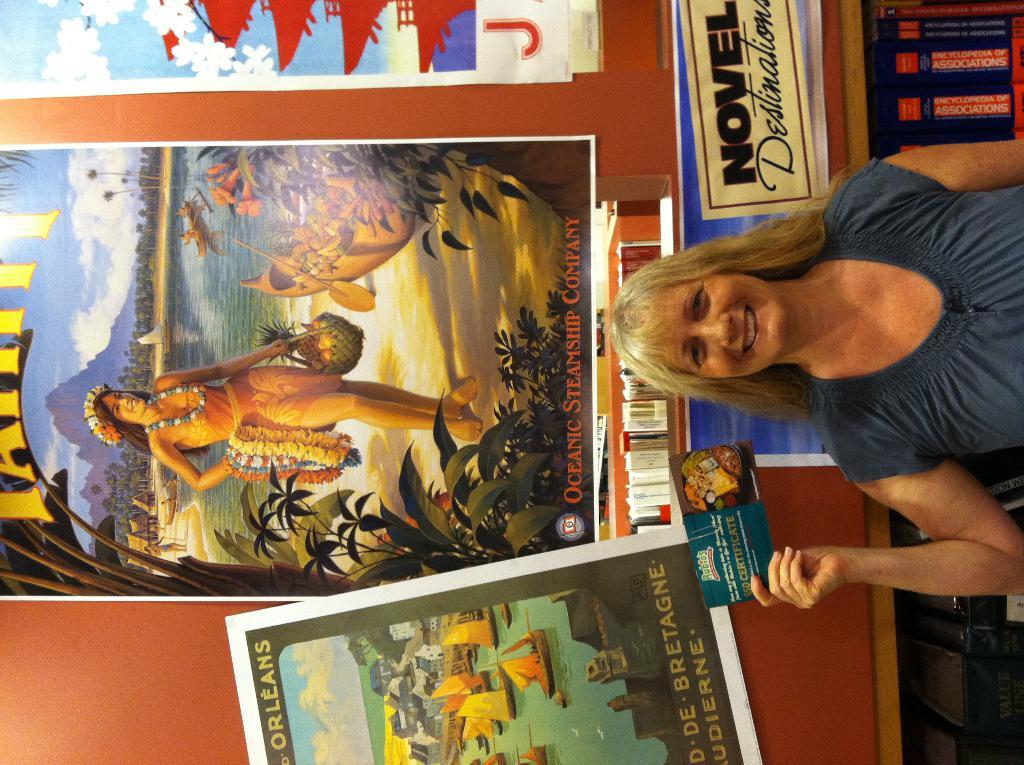<image>
Provide a brief description of the given image. A woman standing in front of a Oceanic Steamship Company poster. 